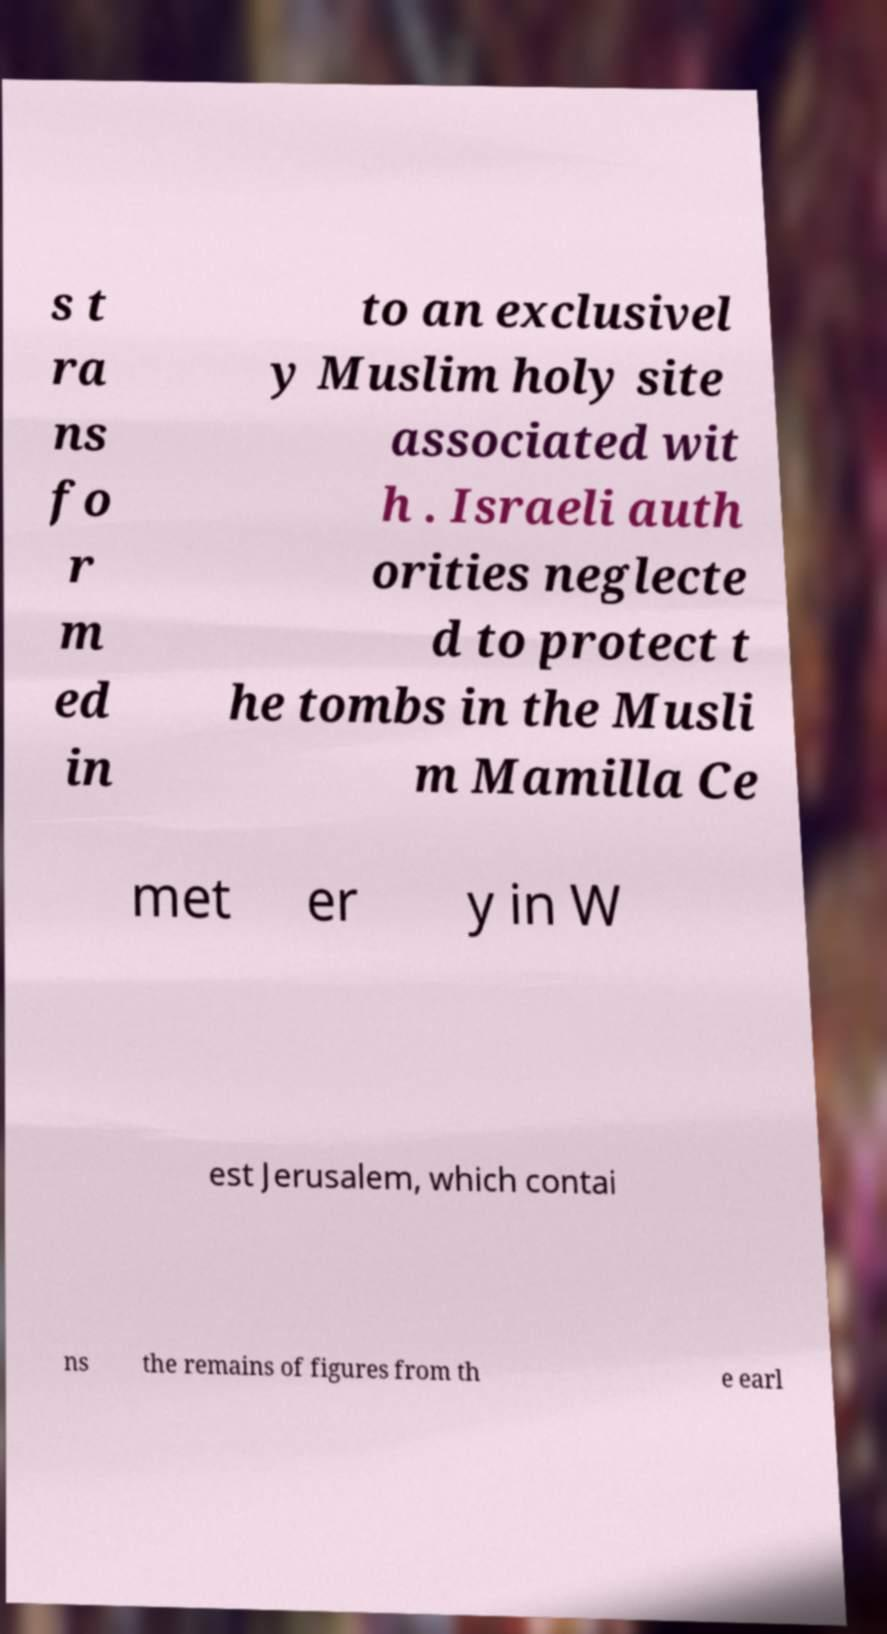There's text embedded in this image that I need extracted. Can you transcribe it verbatim? s t ra ns fo r m ed in to an exclusivel y Muslim holy site associated wit h . Israeli auth orities neglecte d to protect t he tombs in the Musli m Mamilla Ce met er y in W est Jerusalem, which contai ns the remains of figures from th e earl 